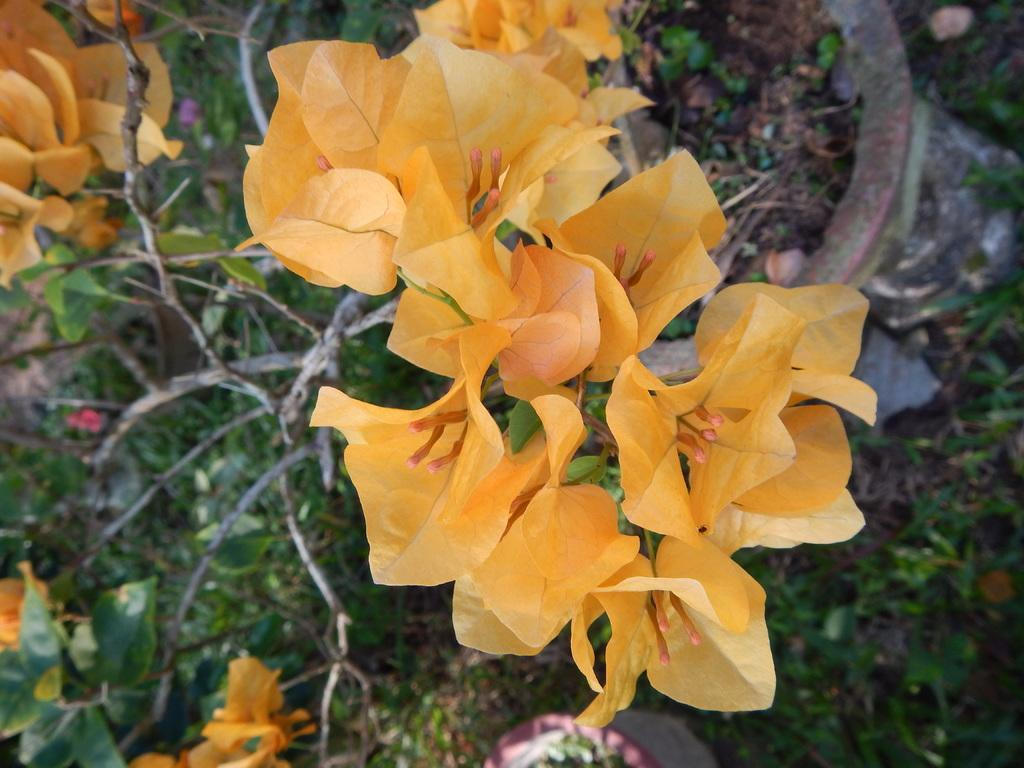What type of plants can be seen in the image? There are flowers, leaves, and grass in the image. What objects are the plants contained in? There are pots in the image. What additional plant features can be seen in the image? There are branches in the image. What type of curtain can be seen in the image? There is no curtain present in the image; it features plants and their components. 